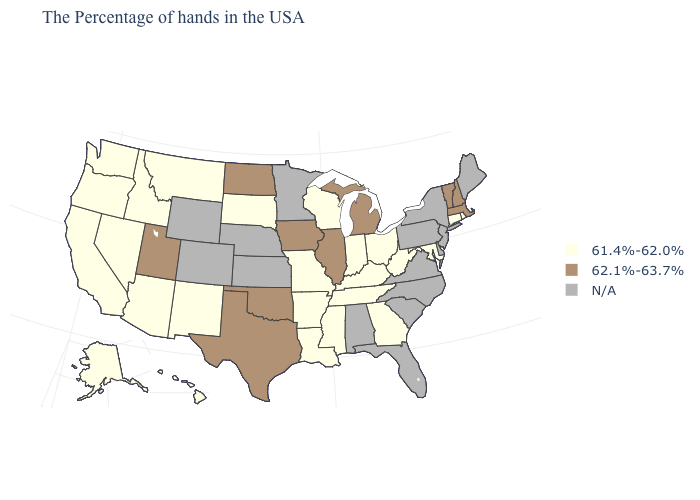Name the states that have a value in the range N/A?
Short answer required. Maine, New York, New Jersey, Delaware, Pennsylvania, Virginia, North Carolina, South Carolina, Florida, Alabama, Minnesota, Kansas, Nebraska, Wyoming, Colorado. Among the states that border Kentucky , does West Virginia have the lowest value?
Answer briefly. Yes. Among the states that border Iowa , which have the highest value?
Keep it brief. Illinois. Name the states that have a value in the range N/A?
Quick response, please. Maine, New York, New Jersey, Delaware, Pennsylvania, Virginia, North Carolina, South Carolina, Florida, Alabama, Minnesota, Kansas, Nebraska, Wyoming, Colorado. Among the states that border Ohio , does Indiana have the lowest value?
Write a very short answer. Yes. What is the value of Minnesota?
Quick response, please. N/A. Name the states that have a value in the range 62.1%-63.7%?
Give a very brief answer. Massachusetts, New Hampshire, Vermont, Michigan, Illinois, Iowa, Oklahoma, Texas, North Dakota, Utah. Name the states that have a value in the range N/A?
Keep it brief. Maine, New York, New Jersey, Delaware, Pennsylvania, Virginia, North Carolina, South Carolina, Florida, Alabama, Minnesota, Kansas, Nebraska, Wyoming, Colorado. Does Oregon have the lowest value in the USA?
Be succinct. Yes. Name the states that have a value in the range 61.4%-62.0%?
Concise answer only. Rhode Island, Connecticut, Maryland, West Virginia, Ohio, Georgia, Kentucky, Indiana, Tennessee, Wisconsin, Mississippi, Louisiana, Missouri, Arkansas, South Dakota, New Mexico, Montana, Arizona, Idaho, Nevada, California, Washington, Oregon, Alaska, Hawaii. What is the value of Maryland?
Concise answer only. 61.4%-62.0%. What is the value of Pennsylvania?
Concise answer only. N/A. What is the value of Oregon?
Give a very brief answer. 61.4%-62.0%. What is the value of Delaware?
Be succinct. N/A. 